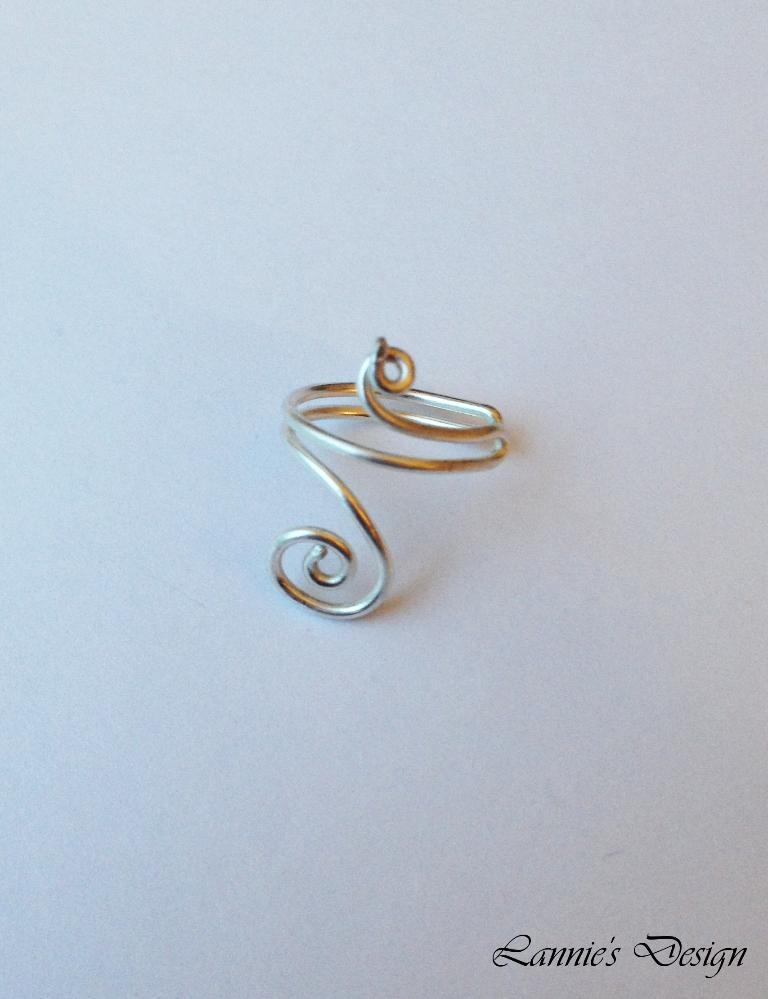What is the main object in the image? There is a ring in the image. What is the color of the surface the ring is on? The ring is on a white surface. Is there any text visible in the image? Yes, there is some text at the bottom right corner of the image. Can you see a fan at the seashore in the image? There is no fan or seashore present in the image; it only features a ring on a white surface with some text at the bottom right corner. 